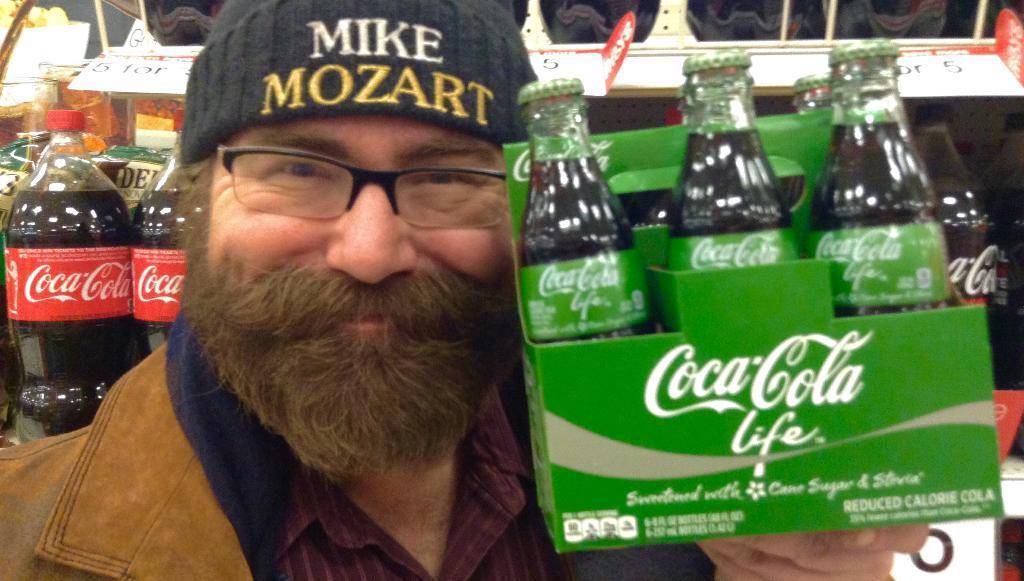Describe this image in one or two sentences. In this image I can see a man wearing shirt and black color cap on his head and also he's holding a box of bottles in his hand. In the background also there are some bottles are there in the rack. 